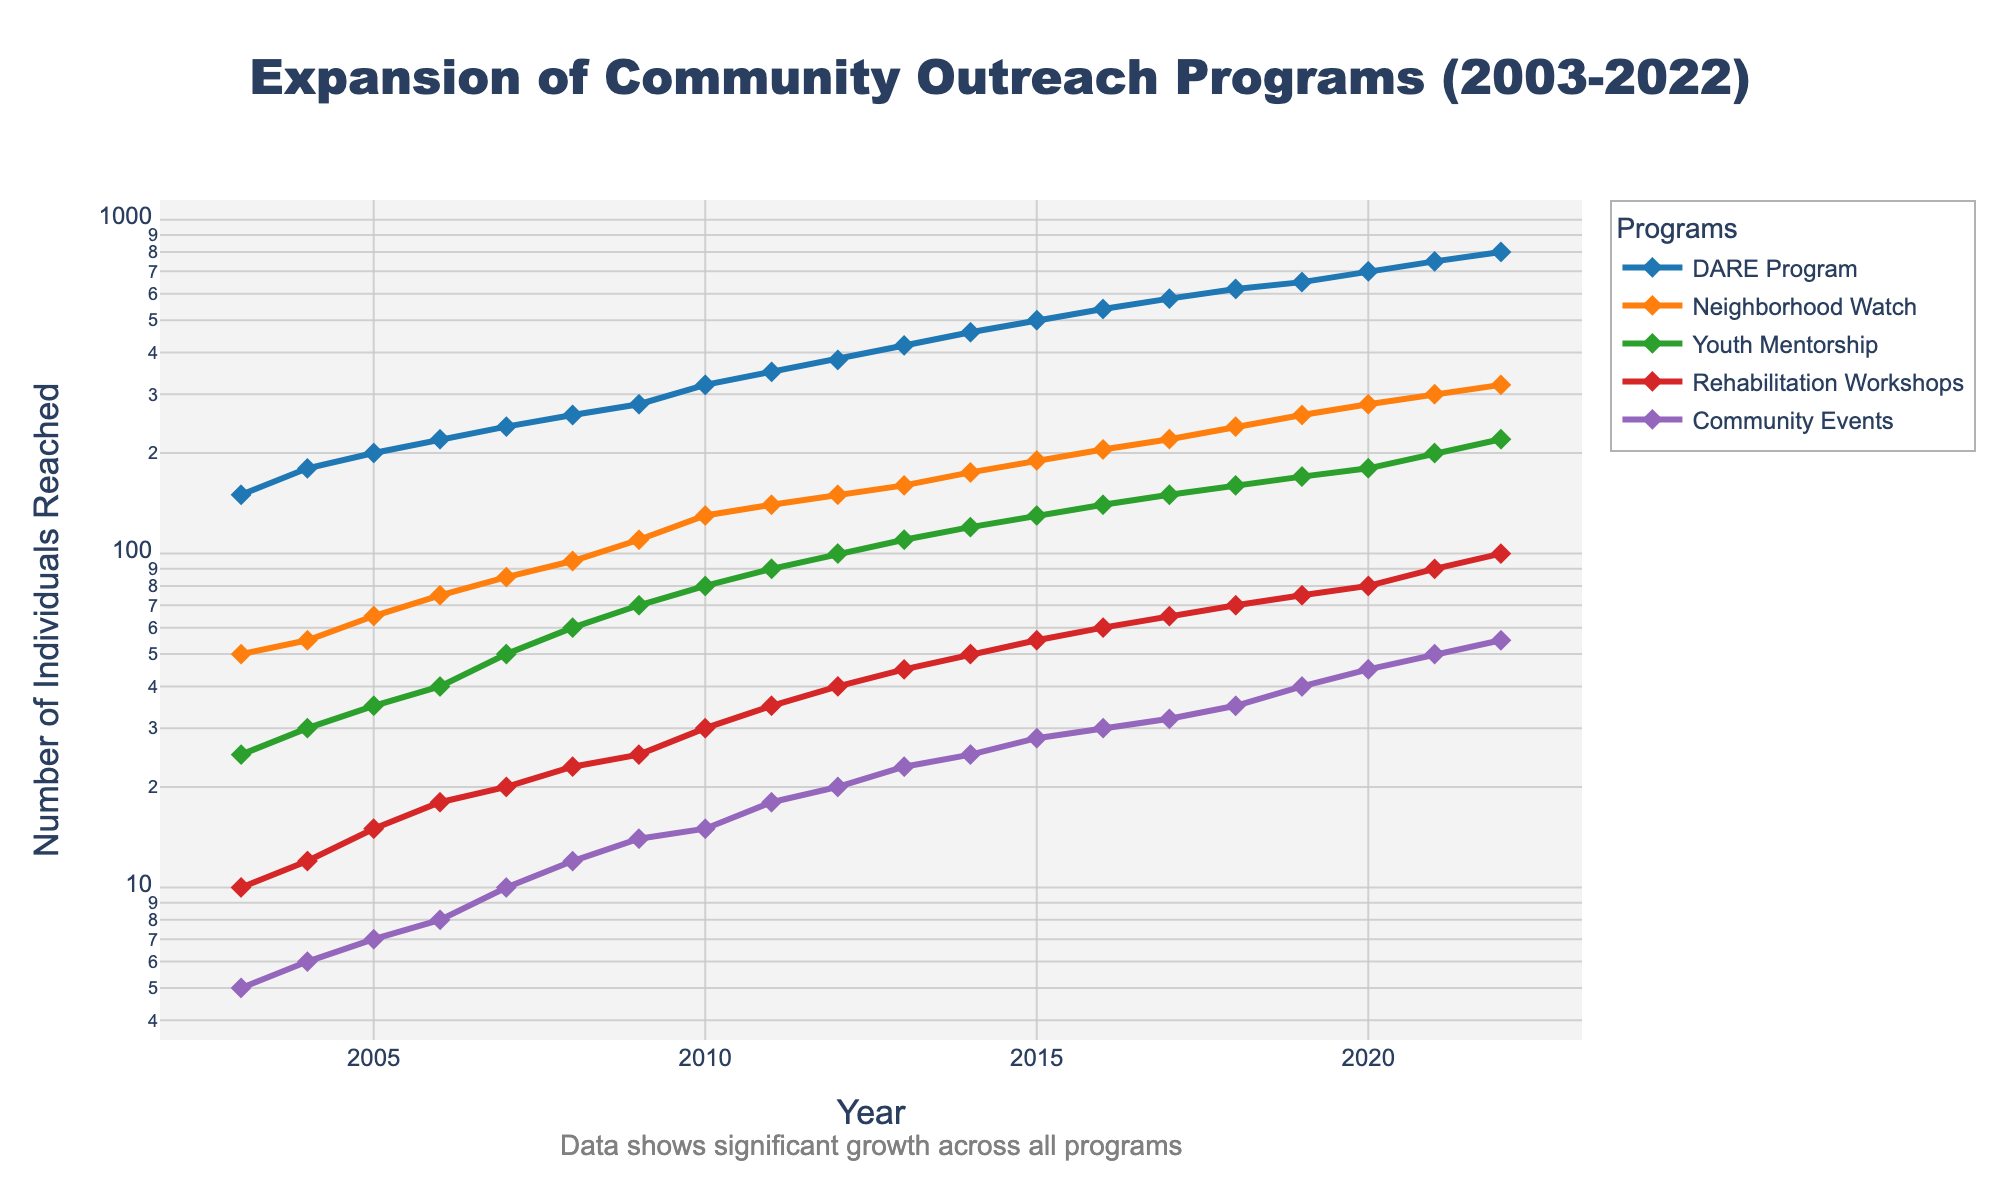What is the title of the plot? The title of the plot is given at the top center and reads "Expansion of Community Outreach Programs (2003-2022)".
Answer: Expansion of Community Outreach Programs (2003-2022) Which program shows the highest number of individuals reached in 2022? By looking at the endpoints of each line on the Y-axis for the year 2022, the DARE Program reaches the highest number of individuals.
Answer: DARE Program How many individuals did the Youth Mentorship program reach in 2010? Locate the data point for Youth Mentorship on the plot at the year 2010 which corresponds to 80 individuals.
Answer: 80 What is the color of the Neighborhood Watch program line? The color assigned to the Neighborhood Watch program is displayed in the legend, which is orange.
Answer: Orange Which program shows the steepest growth from 2003 to 2022? By observing the slope of the lines, the DARE Program has the steepest slope, indicating the highest rate of growth.
Answer: DARE Program How does the scale of the Y-axis affect the representation of data? The Y-axis uses a logarithmic scale, which compresses the data, making exponential growth appear linear and easier to compare.
Answer: It compresses the data for better visualization By how many individuals did the Community Events grow from 2003 to 2022? Subtract the number of individuals reached in 2003 (5) from the number reached in 2022 (55) for the Community Events program. The growth is 55 - 5 = 50 individuals.
Answer: 50 Compare the number of individuals reached by Rehabilitation Workshops and Community Events in 2015. Which program reached more people and by how much? In 2015, Rehabilitation Workshops reached 55, and Community Events reached 28. The difference is 55 - 28 = 27 individuals, with Rehabilitation Workshops reaching more.
Answer: Rehabilitation Workshops by 27 What is the overall trend seen in the Community Outreach Programs over the past 20 years? The overall trend shows significant growth in all programs, as suggested by ascending lines from 2003 to 2022 on the log scale Y-axis.
Answer: Significant growth How many programs reached at least 200 individuals by the year 2022? Check the endpoint values for each program in 2022, DARE Program (800), Neighborhood Watch (320), Youth Mentorship (220), and Rehabilitation Workshops (100). Only the first three reached at least 200 individuals.
Answer: 3 